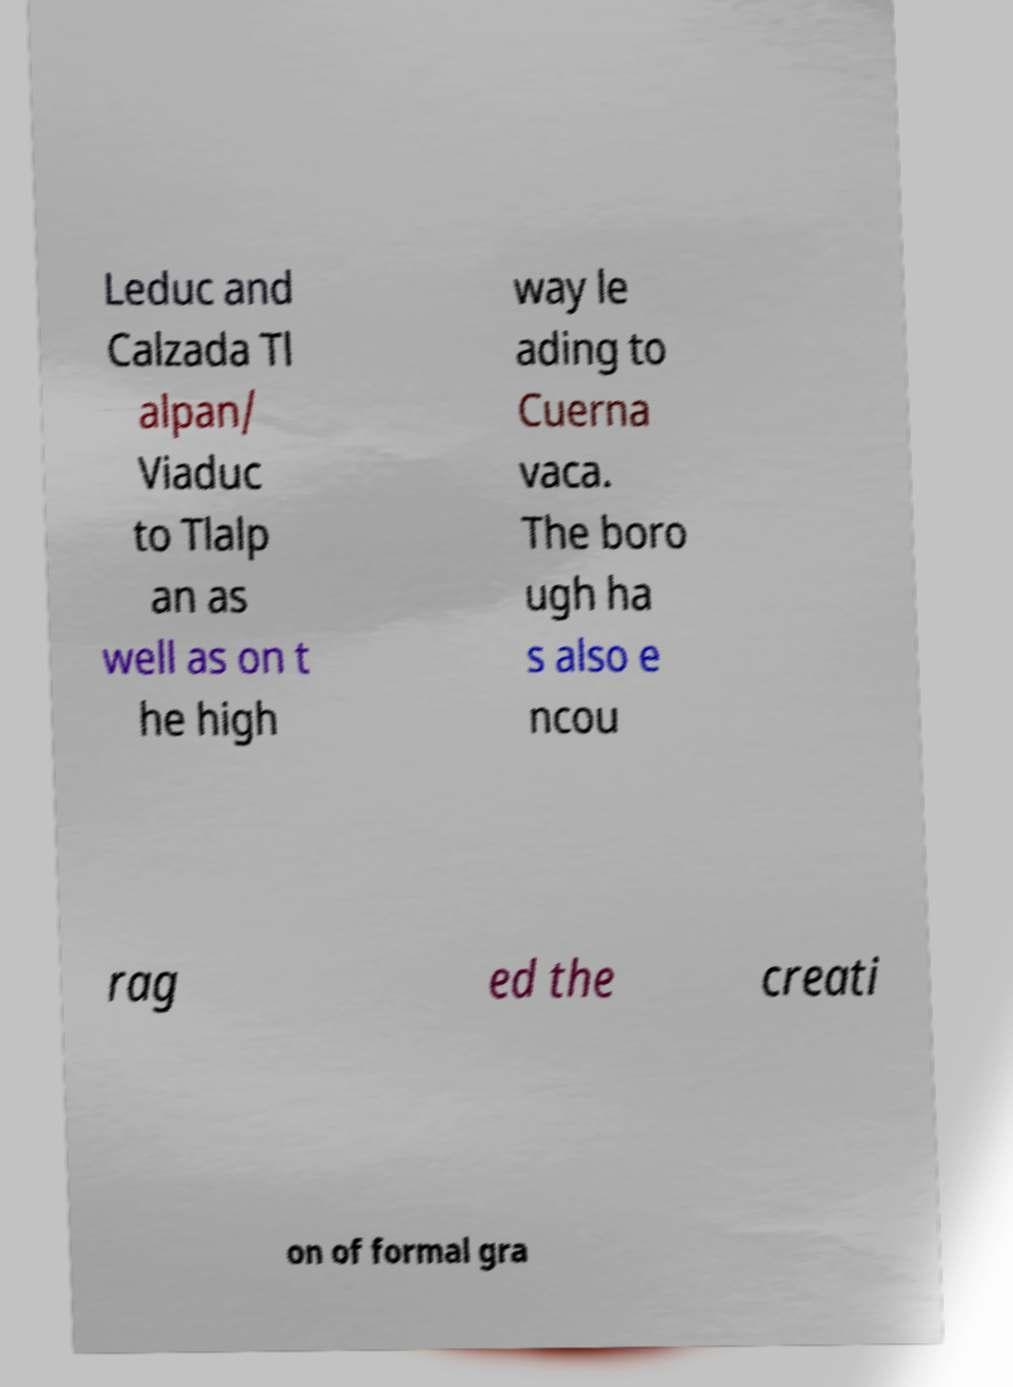Can you accurately transcribe the text from the provided image for me? Leduc and Calzada Tl alpan/ Viaduc to Tlalp an as well as on t he high way le ading to Cuerna vaca. The boro ugh ha s also e ncou rag ed the creati on of formal gra 